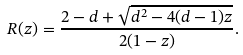Convert formula to latex. <formula><loc_0><loc_0><loc_500><loc_500>R ( z ) = \frac { 2 - d + \sqrt { d ^ { 2 } - 4 ( d - 1 ) z } } { 2 ( 1 - z ) } .</formula> 